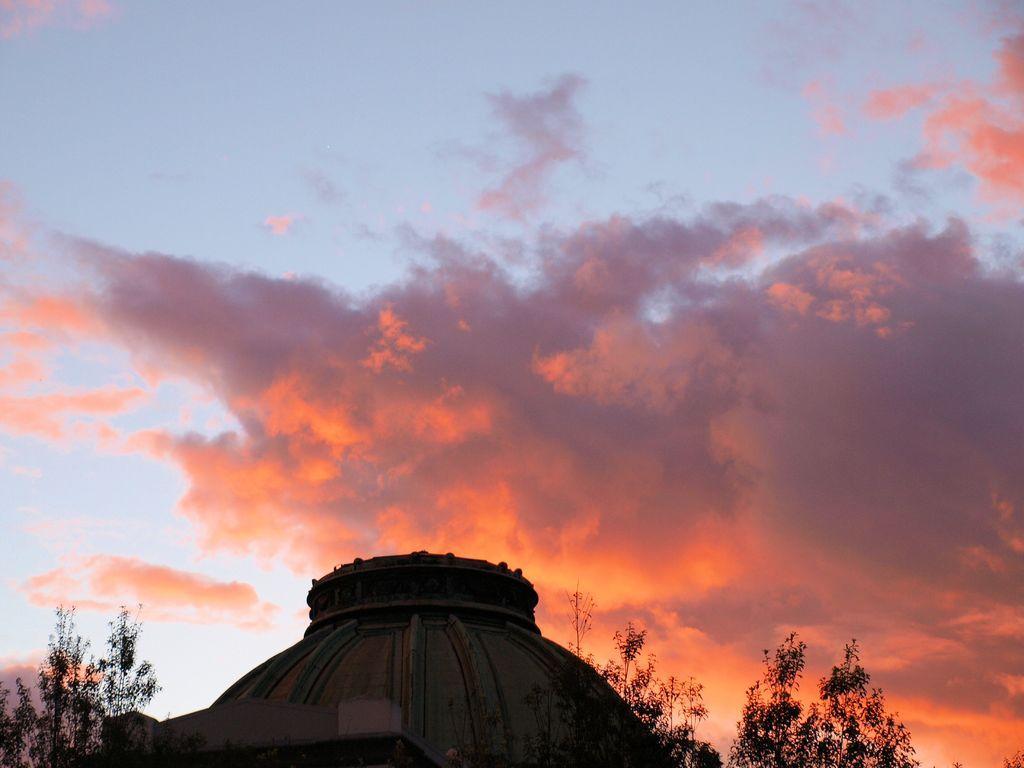Describe this image in one or two sentences. In this picture I can see trees and a blue cloudy sky and It looks like a monument. 